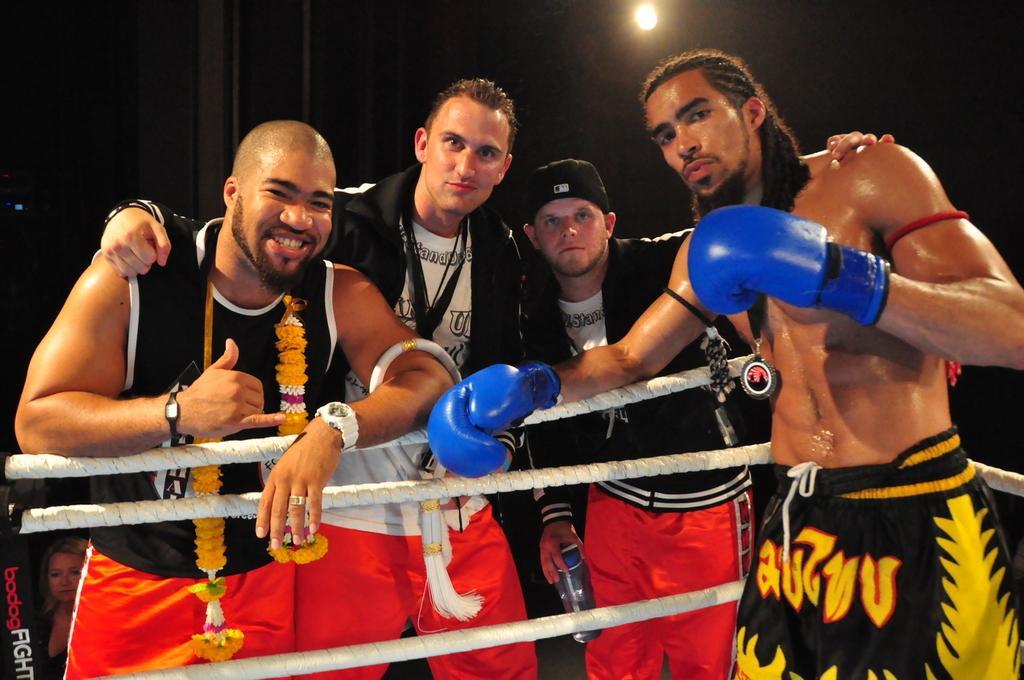Please provide a concise description of this image. Background portion of the picture is dark. At the top we can see a light. In this picture we can see a boxer, wearing boxing gloves in blue color. We can see three men and they all are standing near to the ropes and giving a pose. In the bottom left corner we can see a woman and there is something written. 